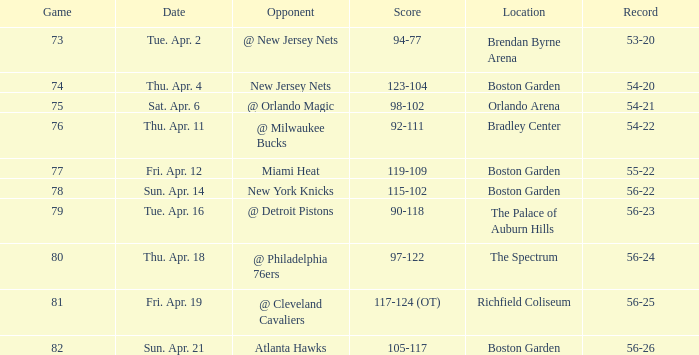Which Opponent has a Score of 92-111? @ Milwaukee Bucks. 